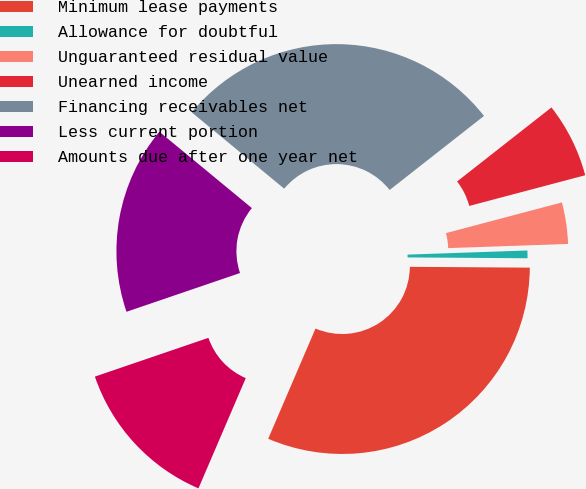Convert chart to OTSL. <chart><loc_0><loc_0><loc_500><loc_500><pie_chart><fcel>Minimum lease payments<fcel>Allowance for doubtful<fcel>Unguaranteed residual value<fcel>Unearned income<fcel>Financing receivables net<fcel>Less current portion<fcel>Amounts due after one year net<nl><fcel>31.34%<fcel>0.66%<fcel>3.57%<fcel>6.47%<fcel>28.43%<fcel>16.22%<fcel>13.31%<nl></chart> 